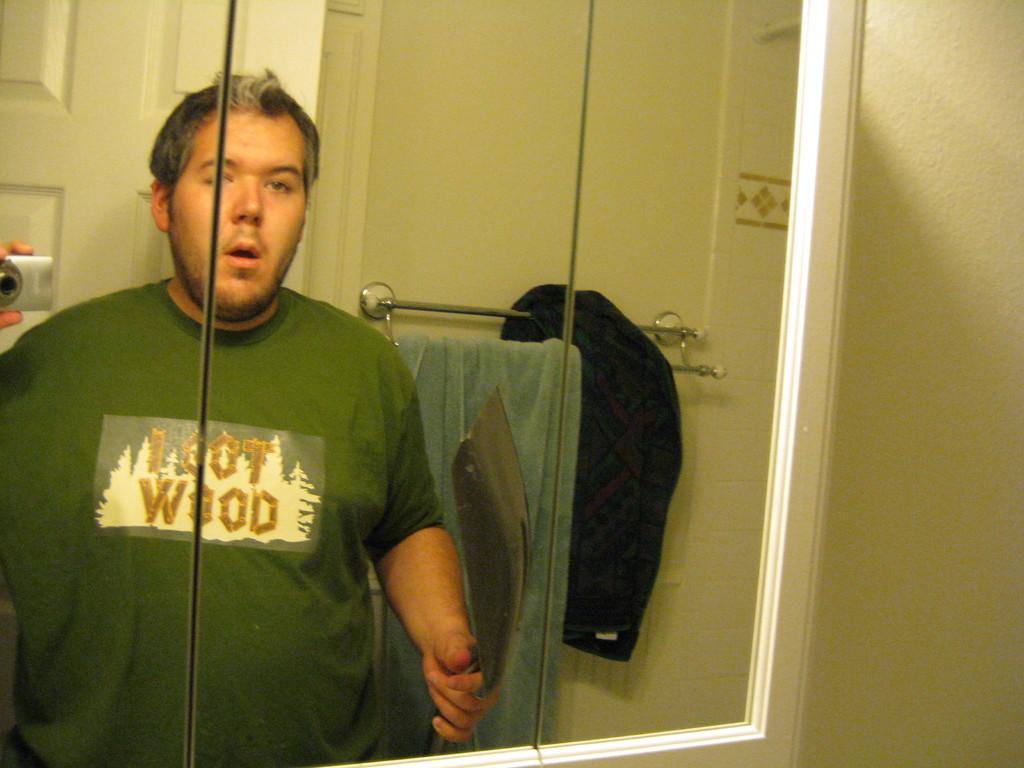<image>
Describe the image concisely. Man looking in to a mirror with a green shirt on that has gold lettering I got wood. 